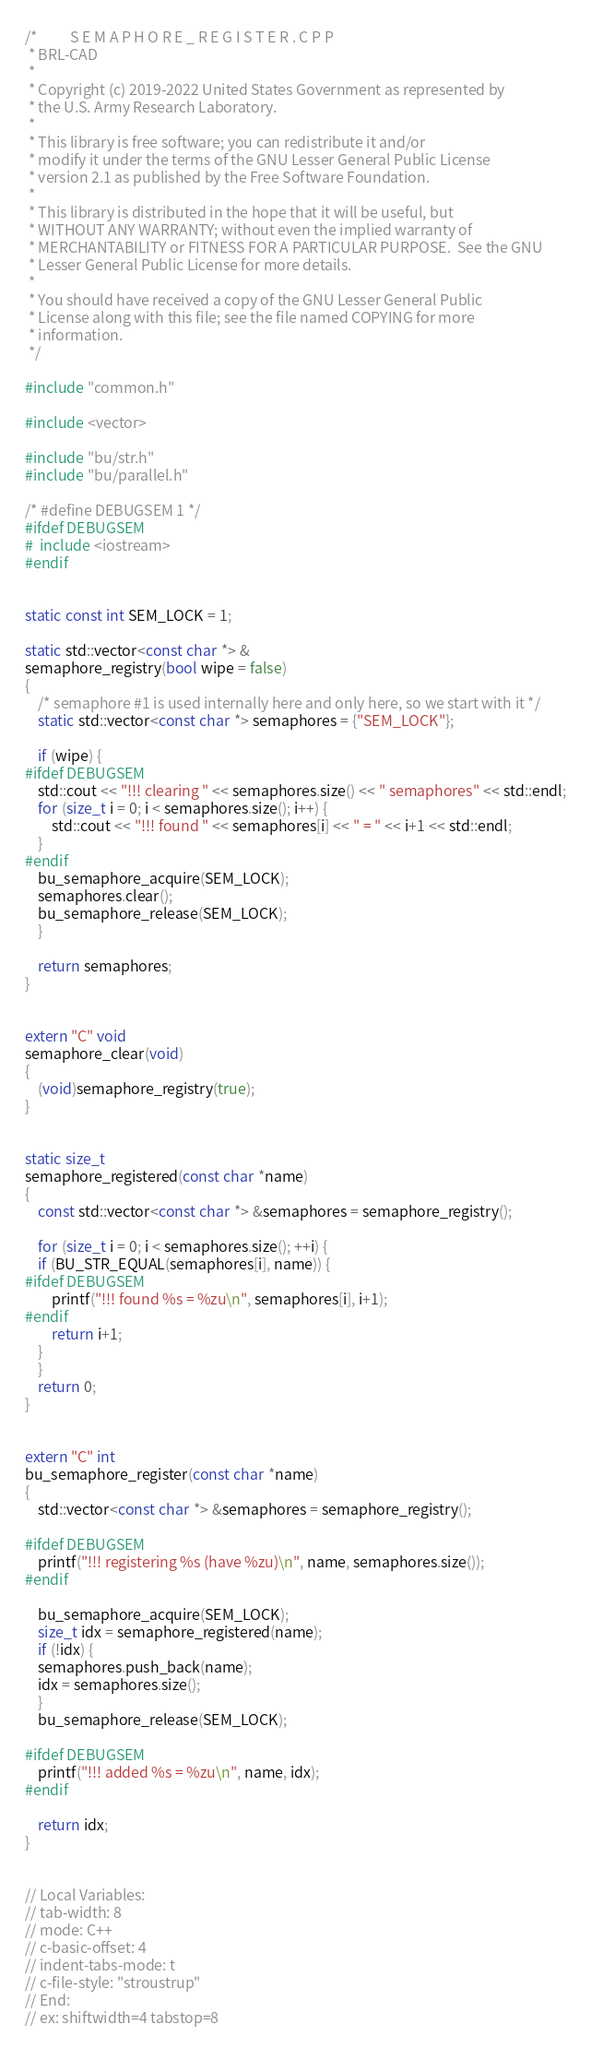<code> <loc_0><loc_0><loc_500><loc_500><_C++_>/*          S E M A P H O R E _ R E G I S T E R . C P P
 * BRL-CAD
 *
 * Copyright (c) 2019-2022 United States Government as represented by
 * the U.S. Army Research Laboratory.
 *
 * This library is free software; you can redistribute it and/or
 * modify it under the terms of the GNU Lesser General Public License
 * version 2.1 as published by the Free Software Foundation.
 *
 * This library is distributed in the hope that it will be useful, but
 * WITHOUT ANY WARRANTY; without even the implied warranty of
 * MERCHANTABILITY or FITNESS FOR A PARTICULAR PURPOSE.  See the GNU
 * Lesser General Public License for more details.
 *
 * You should have received a copy of the GNU Lesser General Public
 * License along with this file; see the file named COPYING for more
 * information.
 */

#include "common.h"

#include <vector>

#include "bu/str.h"
#include "bu/parallel.h"

/* #define DEBUGSEM 1 */
#ifdef DEBUGSEM
#  include <iostream>
#endif


static const int SEM_LOCK = 1;

static std::vector<const char *> &
semaphore_registry(bool wipe = false)
{
    /* semaphore #1 is used internally here and only here, so we start with it */
    static std::vector<const char *> semaphores = {"SEM_LOCK"};

    if (wipe) {
#ifdef DEBUGSEM
	std::cout << "!!! clearing " << semaphores.size() << " semaphores" << std::endl;
	for (size_t i = 0; i < semaphores.size(); i++) {
	    std::cout << "!!! found " << semaphores[i] << " = " << i+1 << std::endl;
	}
#endif
	bu_semaphore_acquire(SEM_LOCK);
	semaphores.clear();
	bu_semaphore_release(SEM_LOCK);
    }

    return semaphores;
}


extern "C" void
semaphore_clear(void)
{
    (void)semaphore_registry(true);
}


static size_t
semaphore_registered(const char *name)
{
    const std::vector<const char *> &semaphores = semaphore_registry();

    for (size_t i = 0; i < semaphores.size(); ++i) {
	if (BU_STR_EQUAL(semaphores[i], name)) {
#ifdef DEBUGSEM
	    printf("!!! found %s = %zu\n", semaphores[i], i+1);
#endif
	    return i+1;
	}
    }
    return 0;
}


extern "C" int
bu_semaphore_register(const char *name)
{
    std::vector<const char *> &semaphores = semaphore_registry();

#ifdef DEBUGSEM
    printf("!!! registering %s (have %zu)\n", name, semaphores.size());
#endif

    bu_semaphore_acquire(SEM_LOCK);
    size_t idx = semaphore_registered(name);
    if (!idx) {
	semaphores.push_back(name);
	idx = semaphores.size();
    }
    bu_semaphore_release(SEM_LOCK);

#ifdef DEBUGSEM
    printf("!!! added %s = %zu\n", name, idx);
#endif

    return idx;
}


// Local Variables:
// tab-width: 8
// mode: C++
// c-basic-offset: 4
// indent-tabs-mode: t
// c-file-style: "stroustrup"
// End:
// ex: shiftwidth=4 tabstop=8
</code> 